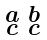Convert formula to latex. <formula><loc_0><loc_0><loc_500><loc_500>\begin{smallmatrix} a & b \\ c & c \end{smallmatrix}</formula> 